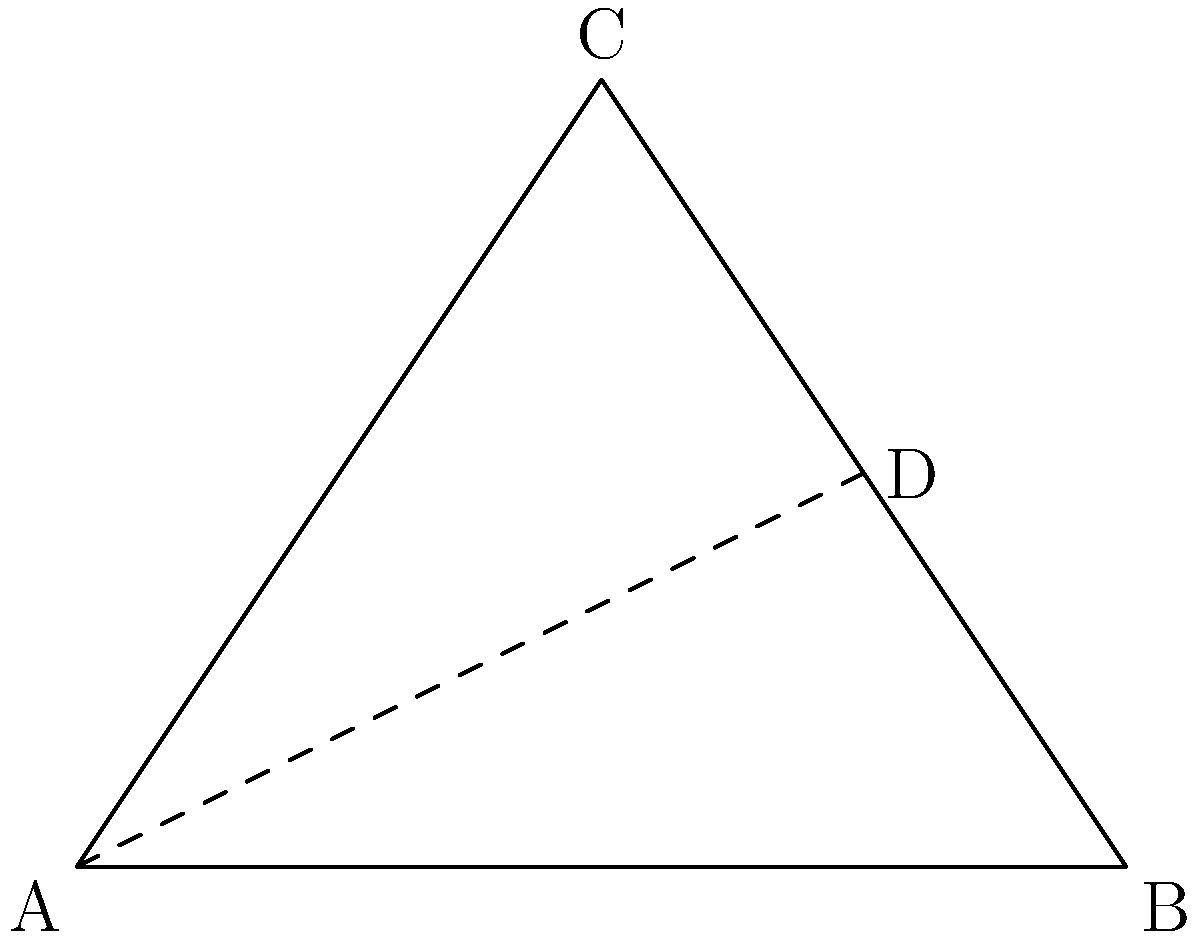In the study of legendary magical wands, a triangle-shaped artifact has been discovered. The wand forms an isosceles triangle ABC, where AB = AC. Point D is the midpoint of side BC. If the length of AD is 5 units and the area of the triangle is 12 square units, what is the length of side BC? Let's approach this step-by-step:

1) First, we know that AD is an altitude of the isosceles triangle, as it bisects the base BC and is perpendicular to it.

2) Let's denote the length of BC as $x$.

3) The area of a triangle is given by the formula: $Area = \frac{1}{2} * base * height$

4) We're given that the area is 12 square units and the height (AD) is 5 units. So:

   $12 = \frac{1}{2} * x * 5$

5) Solving for $x$:
   
   $24 = 5x$
   $x = \frac{24}{5} = 4.8$

6) Therefore, the length of BC is 4.8 units.

7) We can verify this using the Pythagorean theorem in the right triangle ADB:

   $AD^2 + (\frac{BC}{2})^2 = AB^2$

   $5^2 + (\frac{4.8}{2})^2 = AB^2$

   $25 + 5.76 = AB^2$

   $30.76 = AB^2$

   $AB \approx 5.55$ (which is indeed longer than AD, as it should be in this isosceles triangle)
Answer: 4.8 units 